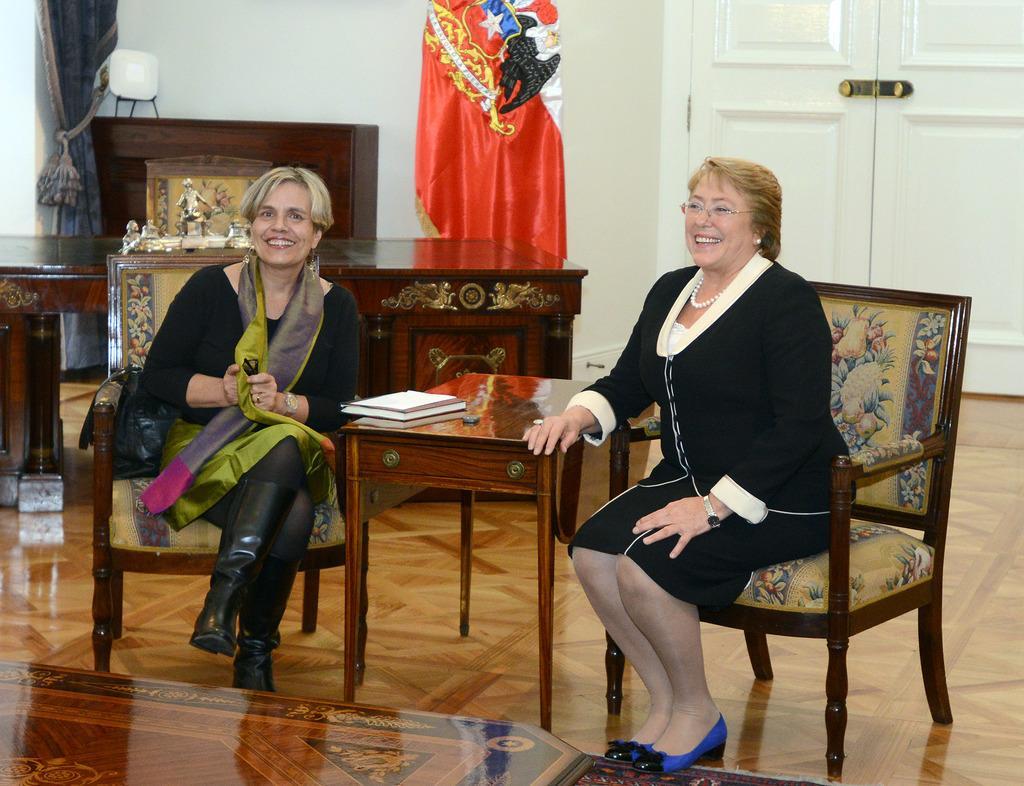Can you describe this image briefly? In this image there are two persons sitting and smiling. In the front there is a table, at the bottom there is a mat, at the left side of the image there is a curtain and table and at the back side there is a door. 